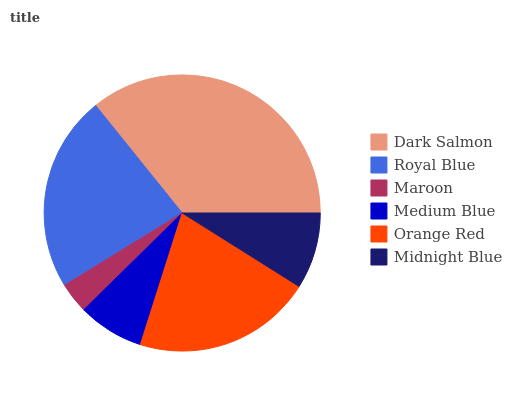Is Maroon the minimum?
Answer yes or no. Yes. Is Dark Salmon the maximum?
Answer yes or no. Yes. Is Royal Blue the minimum?
Answer yes or no. No. Is Royal Blue the maximum?
Answer yes or no. No. Is Dark Salmon greater than Royal Blue?
Answer yes or no. Yes. Is Royal Blue less than Dark Salmon?
Answer yes or no. Yes. Is Royal Blue greater than Dark Salmon?
Answer yes or no. No. Is Dark Salmon less than Royal Blue?
Answer yes or no. No. Is Orange Red the high median?
Answer yes or no. Yes. Is Midnight Blue the low median?
Answer yes or no. Yes. Is Royal Blue the high median?
Answer yes or no. No. Is Royal Blue the low median?
Answer yes or no. No. 